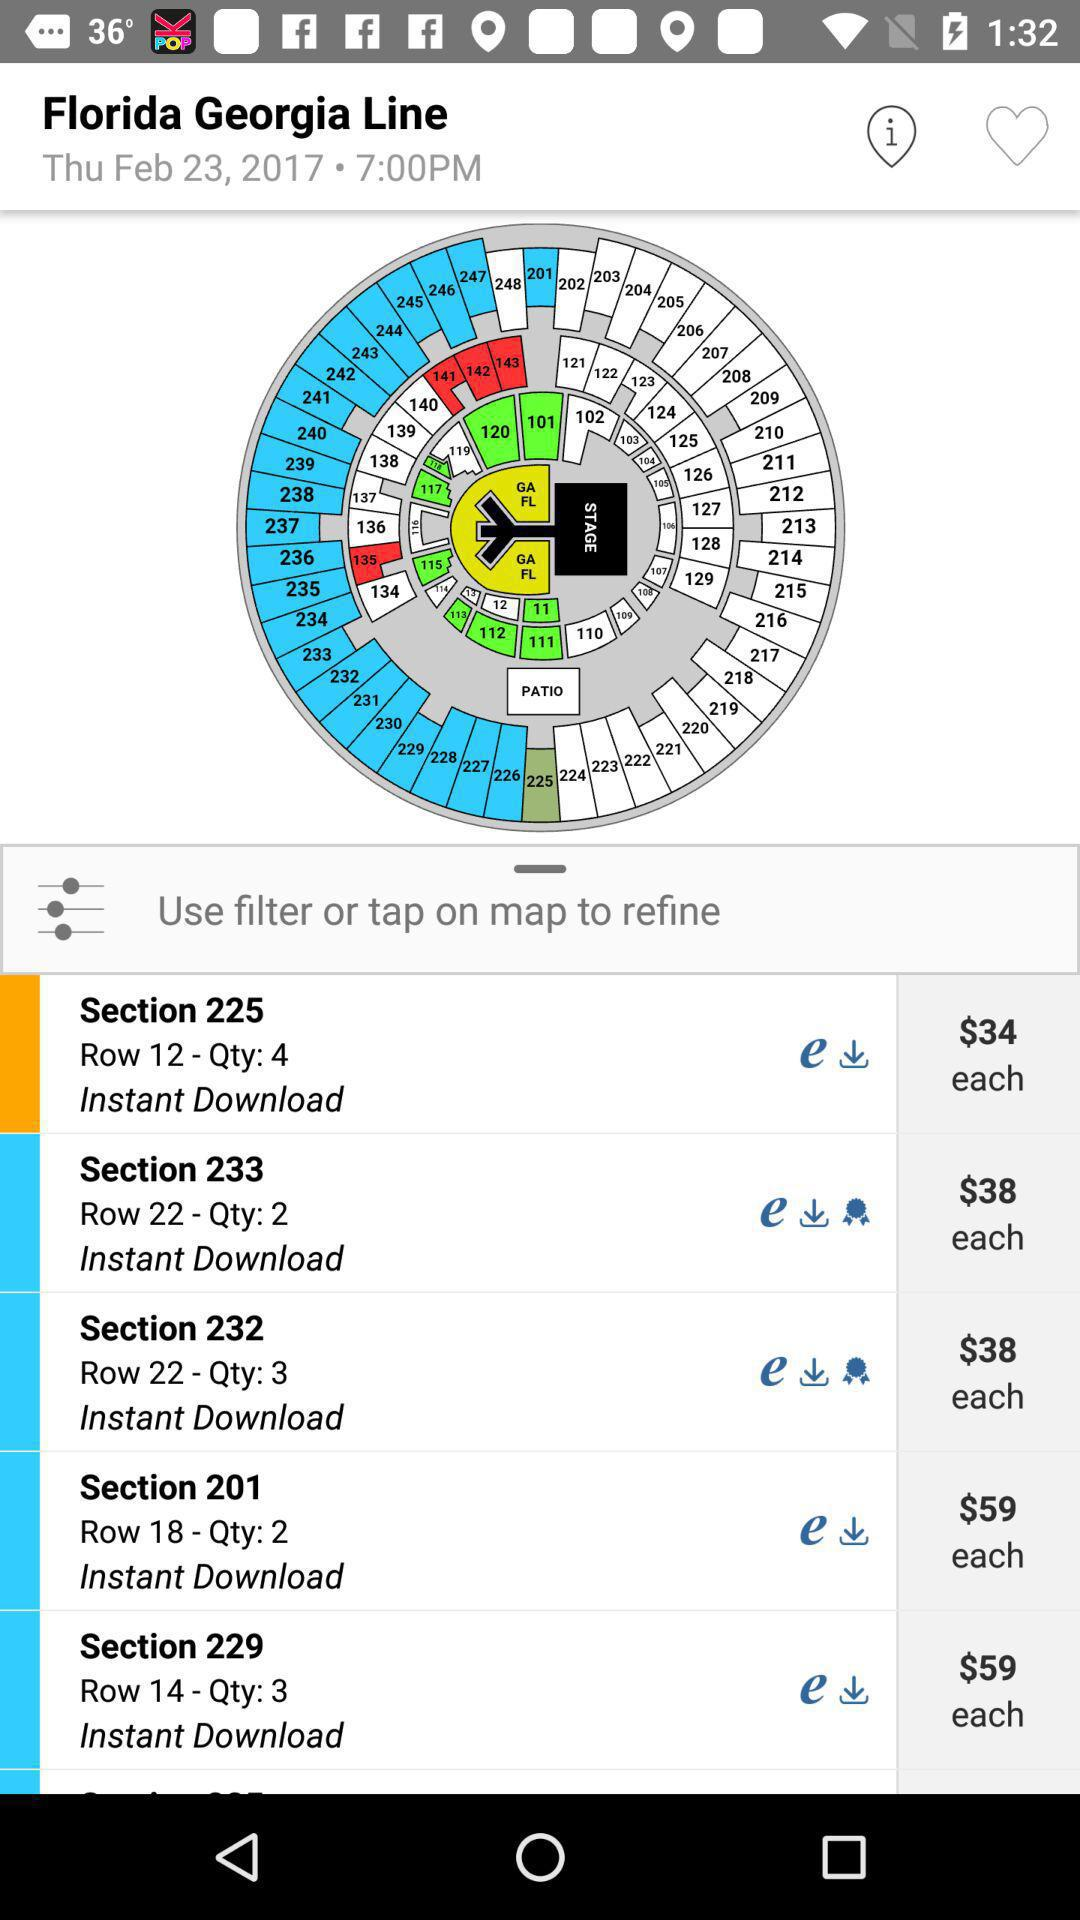What is the date? The date is February 23, 2017. 